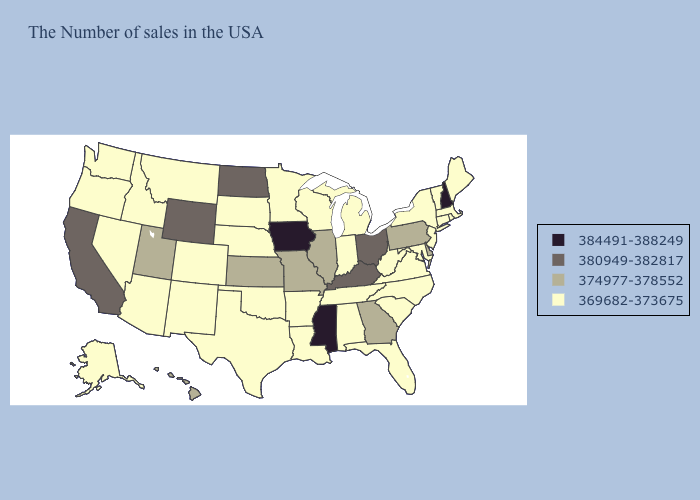Does the map have missing data?
Answer briefly. No. Does Minnesota have the lowest value in the MidWest?
Short answer required. Yes. Does Ohio have the highest value in the USA?
Answer briefly. No. Does New Hampshire have the highest value in the USA?
Quick response, please. Yes. Among the states that border North Carolina , which have the highest value?
Concise answer only. Georgia. Does Missouri have a higher value than Mississippi?
Keep it brief. No. Which states have the highest value in the USA?
Quick response, please. New Hampshire, Mississippi, Iowa. What is the value of Nevada?
Short answer required. 369682-373675. What is the lowest value in states that border Connecticut?
Give a very brief answer. 369682-373675. What is the highest value in the Northeast ?
Give a very brief answer. 384491-388249. Which states hav the highest value in the West?
Keep it brief. Wyoming, California. What is the value of Wisconsin?
Quick response, please. 369682-373675. Name the states that have a value in the range 369682-373675?
Write a very short answer. Maine, Massachusetts, Rhode Island, Vermont, Connecticut, New York, New Jersey, Maryland, Virginia, North Carolina, South Carolina, West Virginia, Florida, Michigan, Indiana, Alabama, Tennessee, Wisconsin, Louisiana, Arkansas, Minnesota, Nebraska, Oklahoma, Texas, South Dakota, Colorado, New Mexico, Montana, Arizona, Idaho, Nevada, Washington, Oregon, Alaska. Name the states that have a value in the range 369682-373675?
Answer briefly. Maine, Massachusetts, Rhode Island, Vermont, Connecticut, New York, New Jersey, Maryland, Virginia, North Carolina, South Carolina, West Virginia, Florida, Michigan, Indiana, Alabama, Tennessee, Wisconsin, Louisiana, Arkansas, Minnesota, Nebraska, Oklahoma, Texas, South Dakota, Colorado, New Mexico, Montana, Arizona, Idaho, Nevada, Washington, Oregon, Alaska. Does the map have missing data?
Keep it brief. No. 